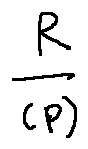<formula> <loc_0><loc_0><loc_500><loc_500>\frac { R } { ( p ) }</formula> 